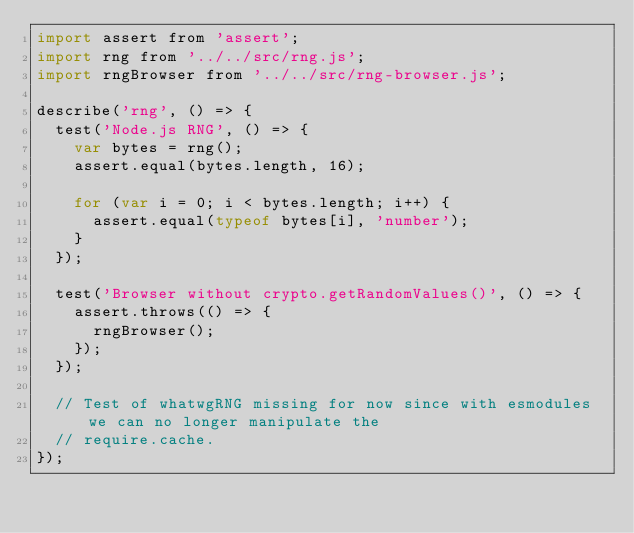Convert code to text. <code><loc_0><loc_0><loc_500><loc_500><_JavaScript_>import assert from 'assert';
import rng from '../../src/rng.js';
import rngBrowser from '../../src/rng-browser.js';

describe('rng', () => {
  test('Node.js RNG', () => {
    var bytes = rng();
    assert.equal(bytes.length, 16);

    for (var i = 0; i < bytes.length; i++) {
      assert.equal(typeof bytes[i], 'number');
    }
  });

  test('Browser without crypto.getRandomValues()', () => {
    assert.throws(() => {
      rngBrowser();
    });
  });

  // Test of whatwgRNG missing for now since with esmodules we can no longer manipulate the
  // require.cache.
});
</code> 